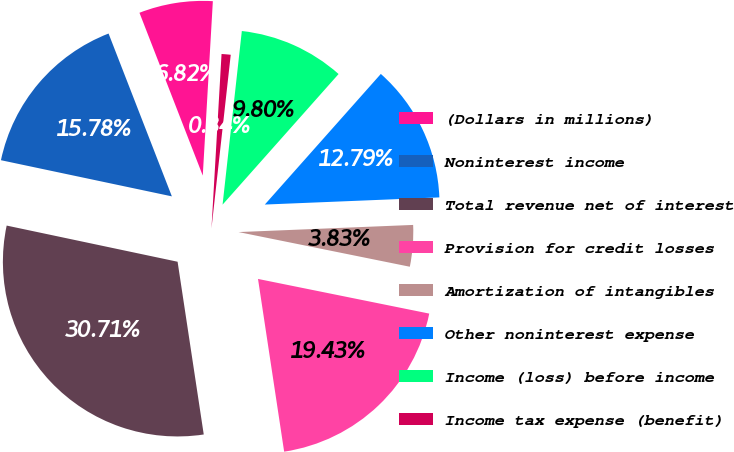Convert chart to OTSL. <chart><loc_0><loc_0><loc_500><loc_500><pie_chart><fcel>(Dollars in millions)<fcel>Noninterest income<fcel>Total revenue net of interest<fcel>Provision for credit losses<fcel>Amortization of intangibles<fcel>Other noninterest expense<fcel>Income (loss) before income<fcel>Income tax expense (benefit)<nl><fcel>6.82%<fcel>15.78%<fcel>30.71%<fcel>19.43%<fcel>3.83%<fcel>12.79%<fcel>9.8%<fcel>0.84%<nl></chart> 